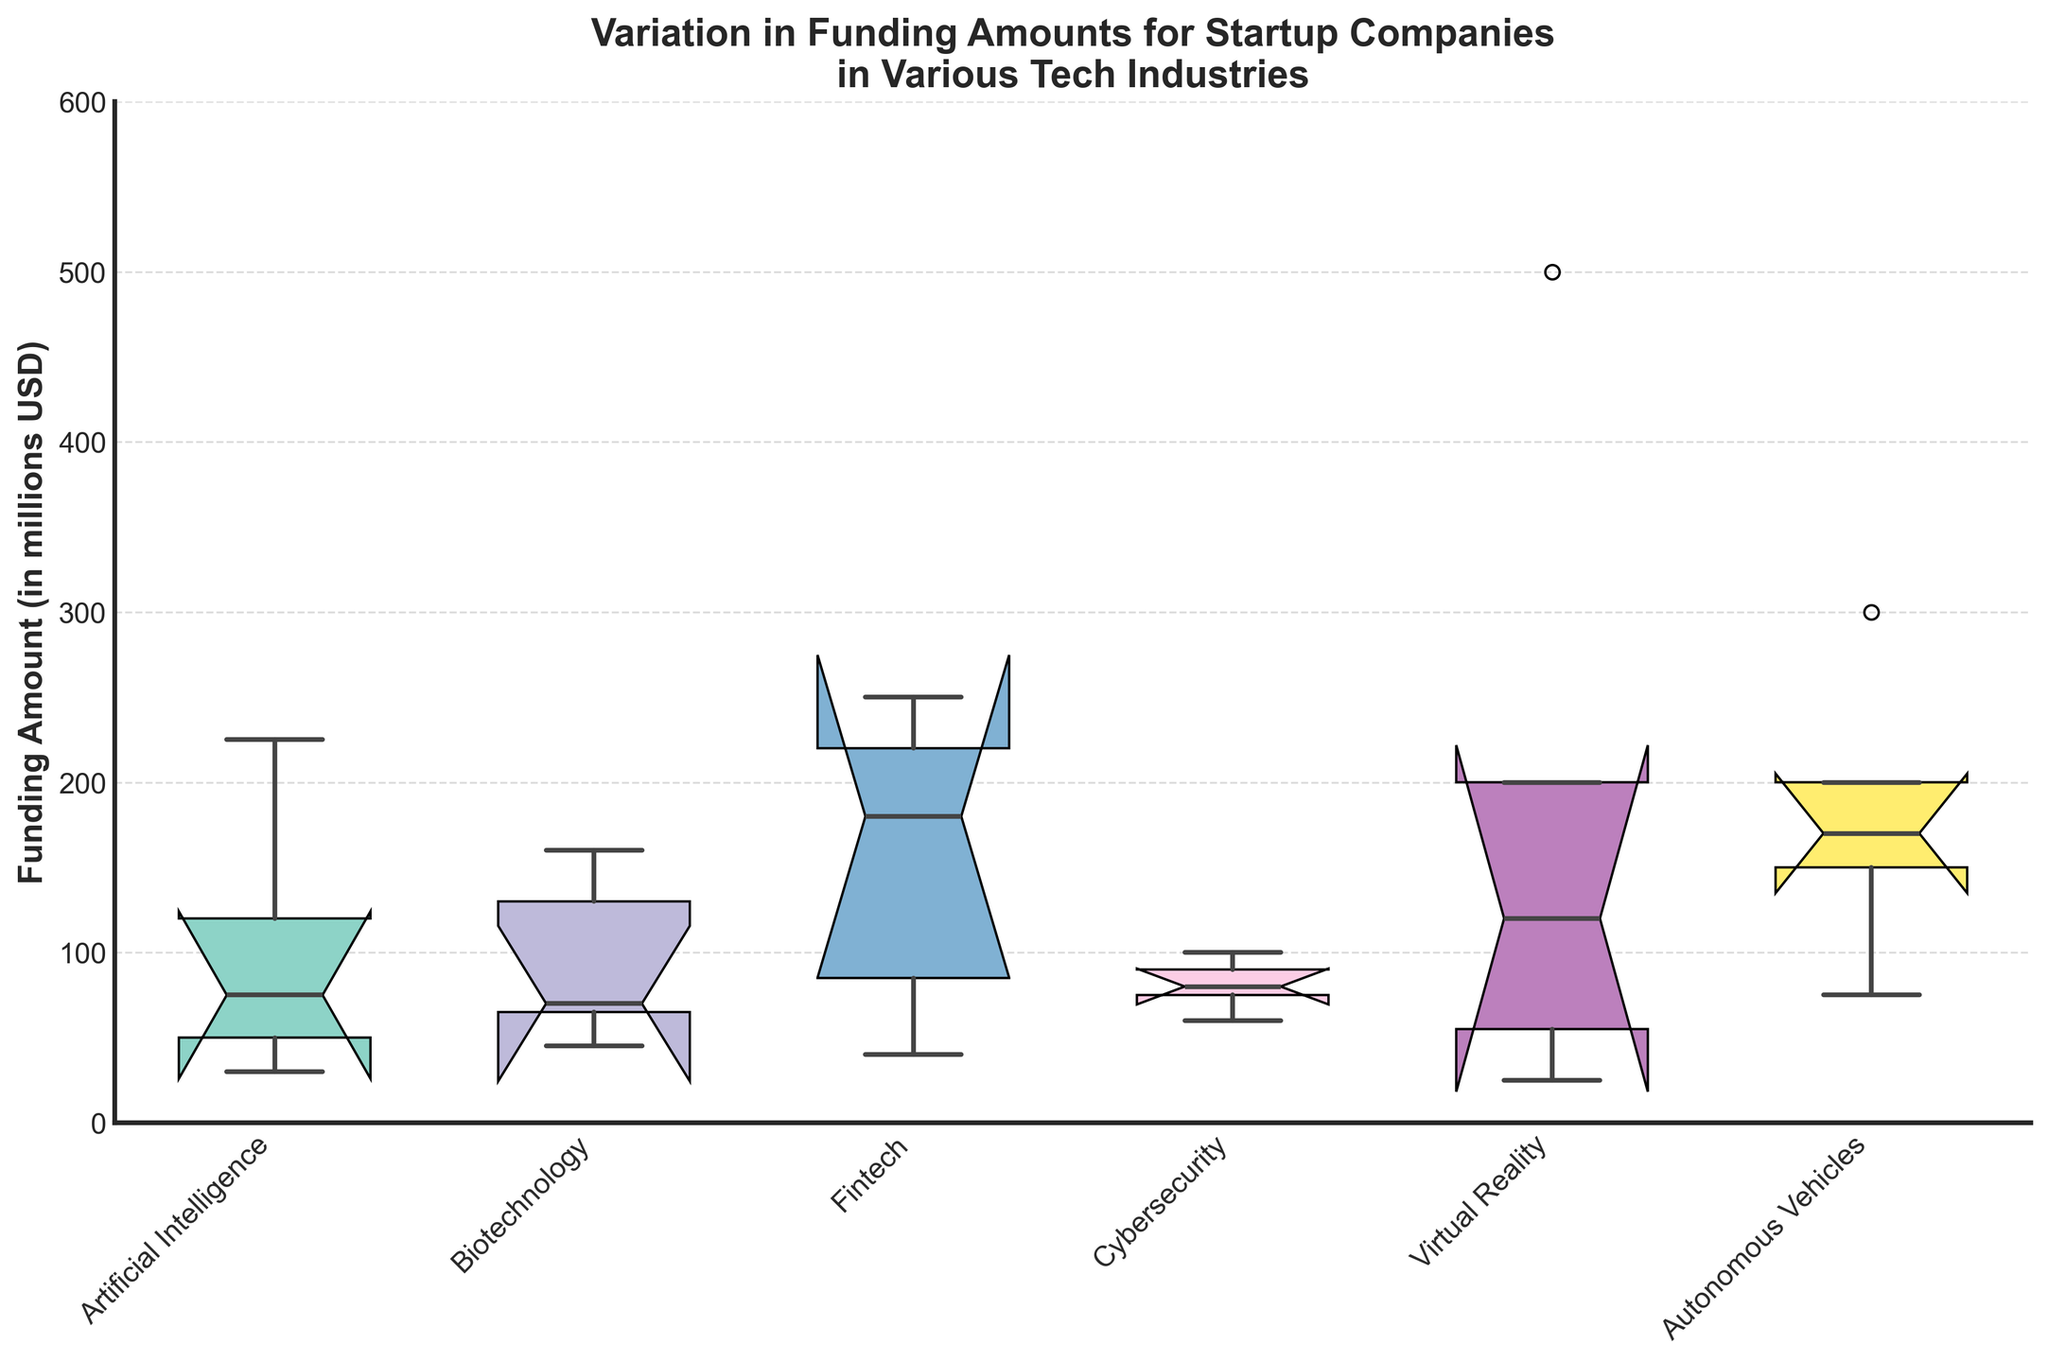How many tech industries are represented in the plot? The x-axis labels show the unique tech industries. Count the labels to determine the number of industries.
Answer: 6 What is the range of funding amounts for the Fintech industry? The box plot for the Fintech industry displays the range from the bottom whisker to the top whisker.
Answer: 40 to 250 Which industry has the highest median funding amount? The horizontal line inside the box represents the median. Compare the medians across industries to find the highest.
Answer: Virtual Reality What is the interquartile range (IQR) for the Artificial Intelligence industry? The IQR is the range between the top and bottom of the box (Q3 - Q1). Measure the values from the plot.
Answer: 120 - 50 = 70 How do the median funding amounts of Autonomous Vehicles and Artificial Intelligence compare? Locate the medians for both industries from the boxes and compare their heights.
Answer: Autonomous Vehicles has a higher median Which industry has the widest spread in funding amounts? The spread can be gauged by the length of the whiskers and the range of data points.
Answer: Virtual Reality For the Cybersecurity industry, what is the approximate funding amount represented by the lower whisker? The lower whisker represents the minimum data point excluding outliers. Check the end of the lower whisker for Cybersecurity.
Answer: 60 Does any industry show funding amounts with outliers outside the interquartile range? Outliers are often marked by points outside the whiskers. Check each industry for these markers.
Answer: No What is the funding amount at the 75th percentile for Biotechnology? The top of the box in the box plot represents the 75th percentile. Look at this value for Biotechnology.
Answer: 130 Which industry has the smallest variation in funding amounts? Smallest variation is indicated by shorter box lengths or whiskers. Compare these across all industries.
Answer: Cybersecurity 